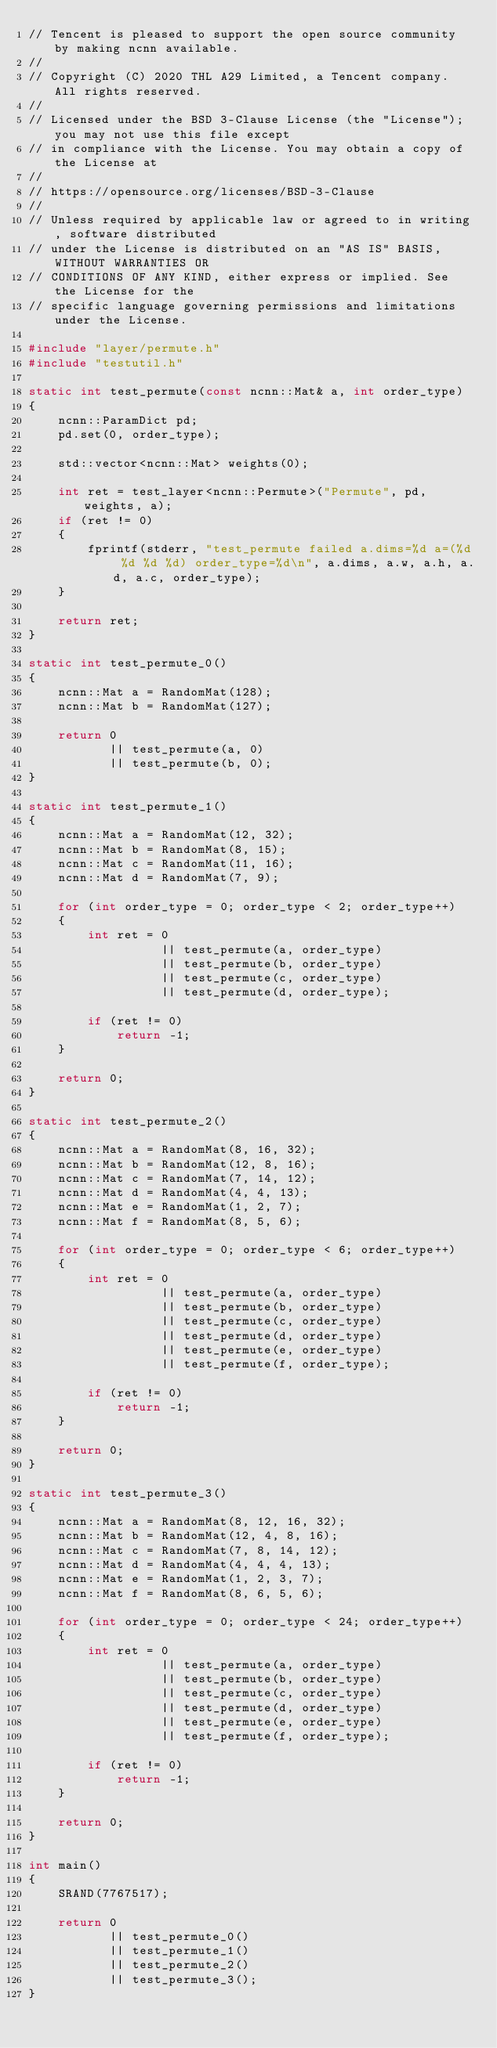<code> <loc_0><loc_0><loc_500><loc_500><_C++_>// Tencent is pleased to support the open source community by making ncnn available.
//
// Copyright (C) 2020 THL A29 Limited, a Tencent company. All rights reserved.
//
// Licensed under the BSD 3-Clause License (the "License"); you may not use this file except
// in compliance with the License. You may obtain a copy of the License at
//
// https://opensource.org/licenses/BSD-3-Clause
//
// Unless required by applicable law or agreed to in writing, software distributed
// under the License is distributed on an "AS IS" BASIS, WITHOUT WARRANTIES OR
// CONDITIONS OF ANY KIND, either express or implied. See the License for the
// specific language governing permissions and limitations under the License.

#include "layer/permute.h"
#include "testutil.h"

static int test_permute(const ncnn::Mat& a, int order_type)
{
    ncnn::ParamDict pd;
    pd.set(0, order_type);

    std::vector<ncnn::Mat> weights(0);

    int ret = test_layer<ncnn::Permute>("Permute", pd, weights, a);
    if (ret != 0)
    {
        fprintf(stderr, "test_permute failed a.dims=%d a=(%d %d %d %d) order_type=%d\n", a.dims, a.w, a.h, a.d, a.c, order_type);
    }

    return ret;
}

static int test_permute_0()
{
    ncnn::Mat a = RandomMat(128);
    ncnn::Mat b = RandomMat(127);

    return 0
           || test_permute(a, 0)
           || test_permute(b, 0);
}

static int test_permute_1()
{
    ncnn::Mat a = RandomMat(12, 32);
    ncnn::Mat b = RandomMat(8, 15);
    ncnn::Mat c = RandomMat(11, 16);
    ncnn::Mat d = RandomMat(7, 9);

    for (int order_type = 0; order_type < 2; order_type++)
    {
        int ret = 0
                  || test_permute(a, order_type)
                  || test_permute(b, order_type)
                  || test_permute(c, order_type)
                  || test_permute(d, order_type);

        if (ret != 0)
            return -1;
    }

    return 0;
}

static int test_permute_2()
{
    ncnn::Mat a = RandomMat(8, 16, 32);
    ncnn::Mat b = RandomMat(12, 8, 16);
    ncnn::Mat c = RandomMat(7, 14, 12);
    ncnn::Mat d = RandomMat(4, 4, 13);
    ncnn::Mat e = RandomMat(1, 2, 7);
    ncnn::Mat f = RandomMat(8, 5, 6);

    for (int order_type = 0; order_type < 6; order_type++)
    {
        int ret = 0
                  || test_permute(a, order_type)
                  || test_permute(b, order_type)
                  || test_permute(c, order_type)
                  || test_permute(d, order_type)
                  || test_permute(e, order_type)
                  || test_permute(f, order_type);

        if (ret != 0)
            return -1;
    }

    return 0;
}

static int test_permute_3()
{
    ncnn::Mat a = RandomMat(8, 12, 16, 32);
    ncnn::Mat b = RandomMat(12, 4, 8, 16);
    ncnn::Mat c = RandomMat(7, 8, 14, 12);
    ncnn::Mat d = RandomMat(4, 4, 4, 13);
    ncnn::Mat e = RandomMat(1, 2, 3, 7);
    ncnn::Mat f = RandomMat(8, 6, 5, 6);

    for (int order_type = 0; order_type < 24; order_type++)
    {
        int ret = 0
                  || test_permute(a, order_type)
                  || test_permute(b, order_type)
                  || test_permute(c, order_type)
                  || test_permute(d, order_type)
                  || test_permute(e, order_type)
                  || test_permute(f, order_type);

        if (ret != 0)
            return -1;
    }

    return 0;
}

int main()
{
    SRAND(7767517);

    return 0
           || test_permute_0()
           || test_permute_1()
           || test_permute_2()
           || test_permute_3();
}
</code> 